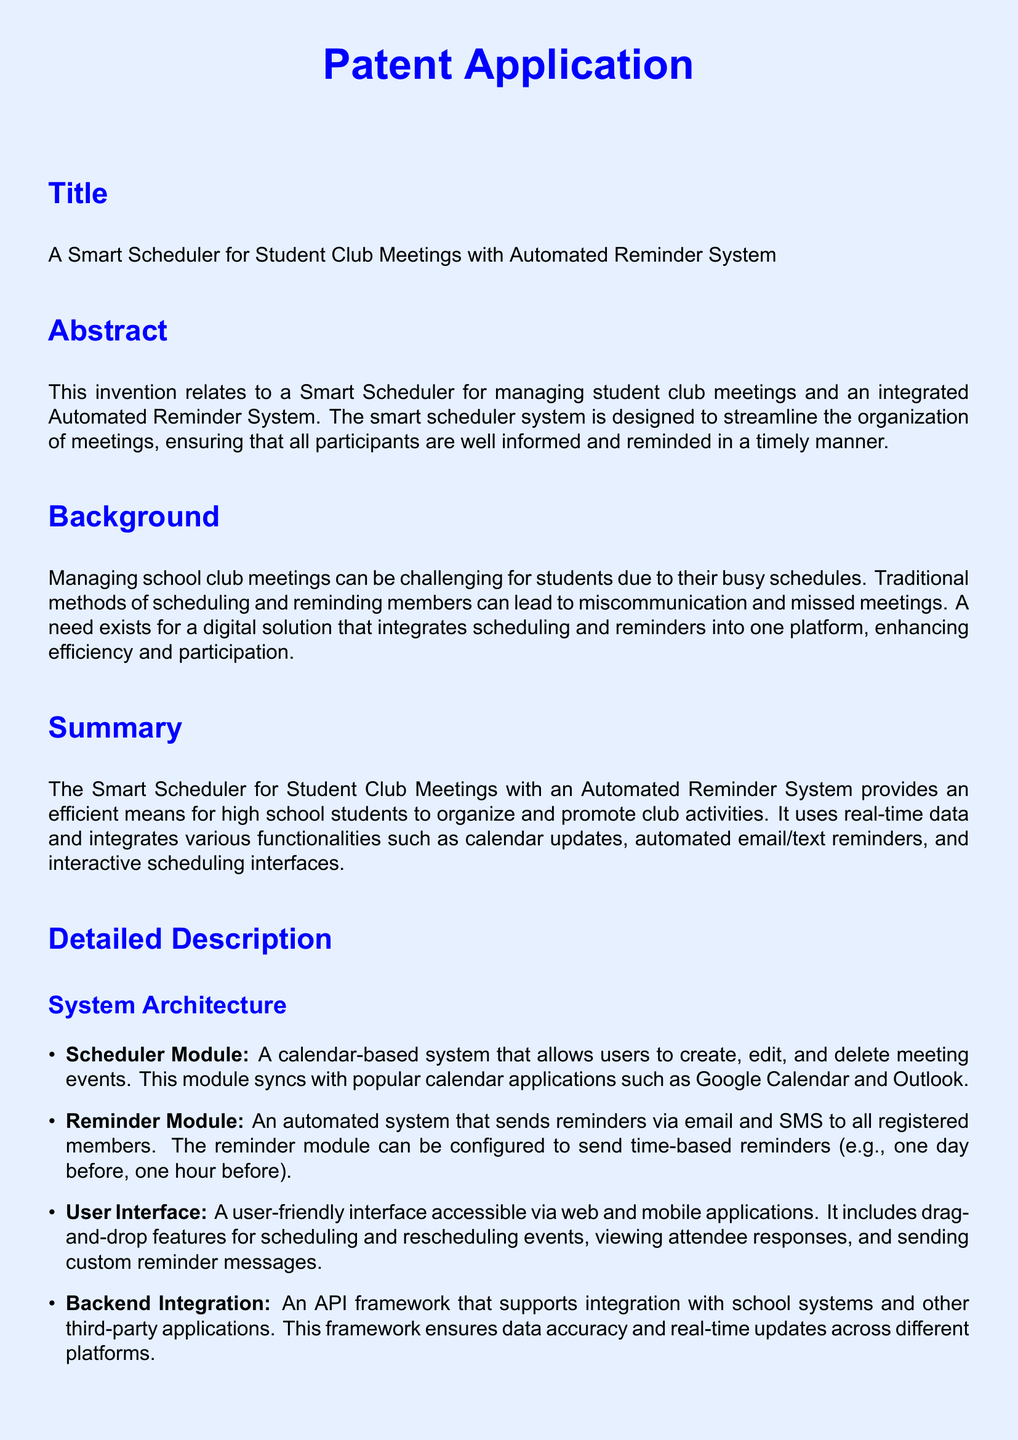what is the title of the patent application? The title is found in the title section of the document, which clearly states the focus of the invention.
Answer: A Smart Scheduler for Student Club Meetings with Automated Reminder System what is the main purpose of the Smart Scheduler? The main purpose is described in the abstract, highlighting the invention's functionality and intent to improve organization.
Answer: To streamline the organization of meetings which modules are included in the system architecture? The system architecture list various modules that are crucial to the functioning of the application, such as the Scheduler Module, Reminder Module, etc.
Answer: Scheduler Module, Reminder Module, User Interface, Backend Integration how many claims are made in this patent application? The claims section of the document specifies the number of claims that define the invention's unique features.
Answer: Three what is one feature of the Reminder Module? The features of the Reminder Module are described in detail, specifying how it operates in terms of reminders sent to users.
Answer: Automated reminders via email and SMS what is the benefit of having a user-friendly interface? The detailed description mentions the user interface, indicating its importance in making the system accessible and easy to use.
Answer: Accessibility what type of reminders can be configured? The document provides specific information about the timing of reminders that can be sent to users before an event occurs.
Answer: Time-based reminders what is the background addressing? The background section explains the challenges faced in scheduling school club meetings and the need for a solution.
Answer: The challenges of managing school club meetings what does the attendance tracking feature do? The claims and key features mention attendance tracking while emphasizing its functionality's importance.
Answer: Track attendees' presence at meetings 